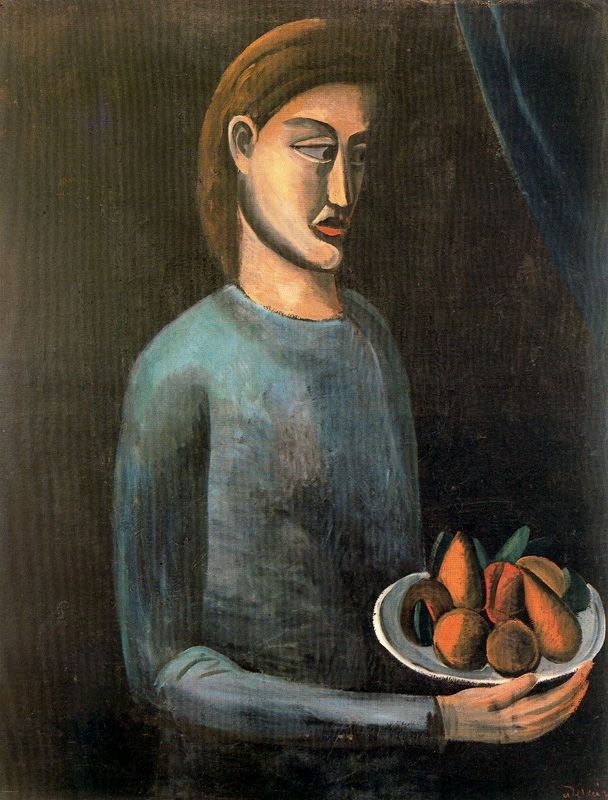What might the colors and style of the painting suggest about the mood or theme of the artwork? The colors, predominantly muted with instances of vibrant hues from the fruit, alongside the modernist style, suggest a duality in mood. The overall dark and subdued palette might evoke a sense of introspection or melancholy, while the bright fruit could symbolize moments of vitality and life. The style, with its simplified forms and less detailed facial expressions, often aims to convey emotional depth and a focus on inner feelings over external realities. 